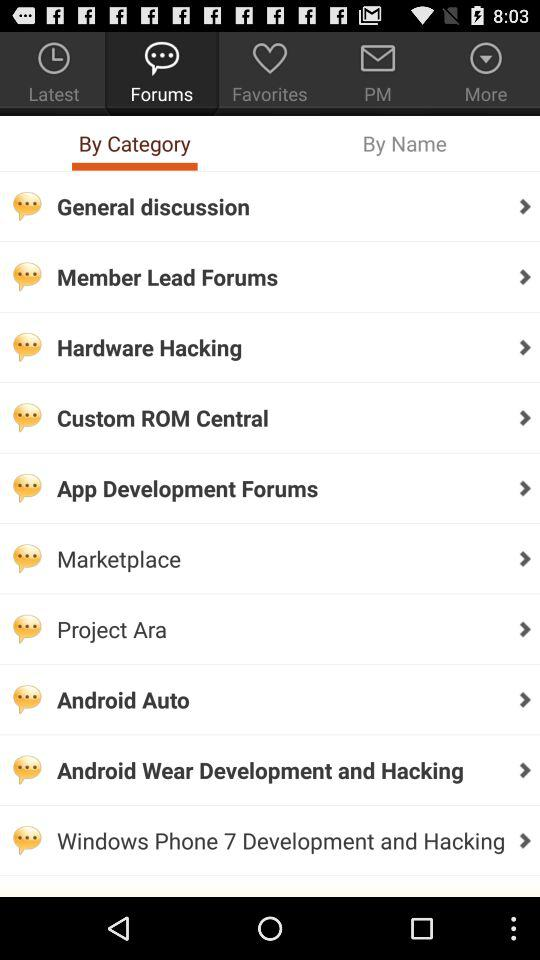Which forum category am I on?
When the provided information is insufficient, respond with <no answer>. <no answer> 